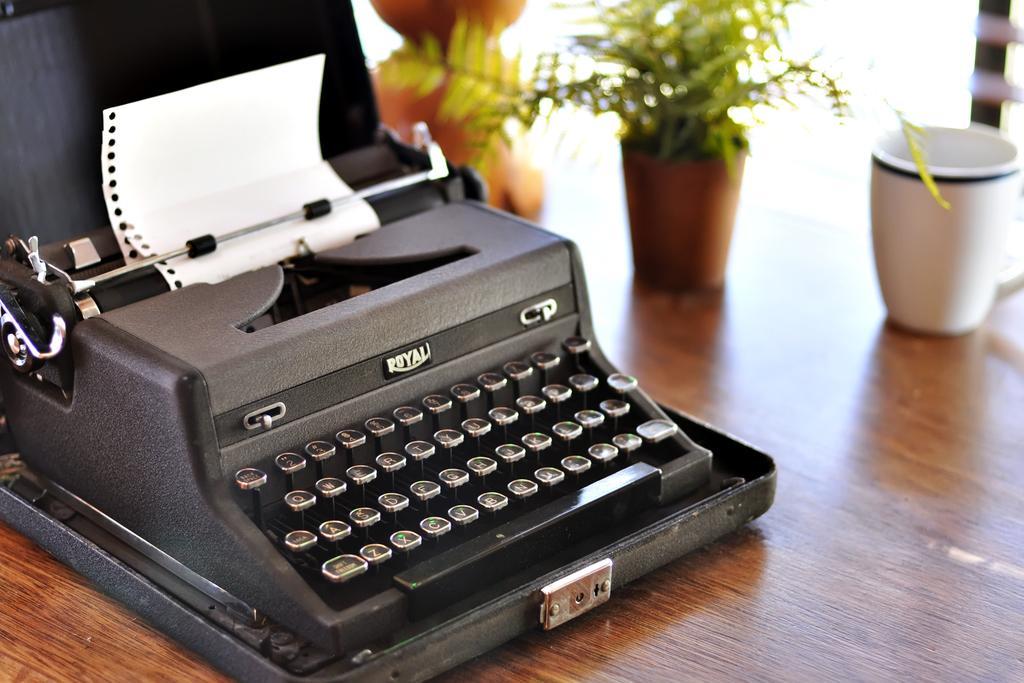Could you give a brief overview of what you see in this image? Towards left we can see a typing machine on a wooden table. At the top there are cup, flower plant and other objects. 